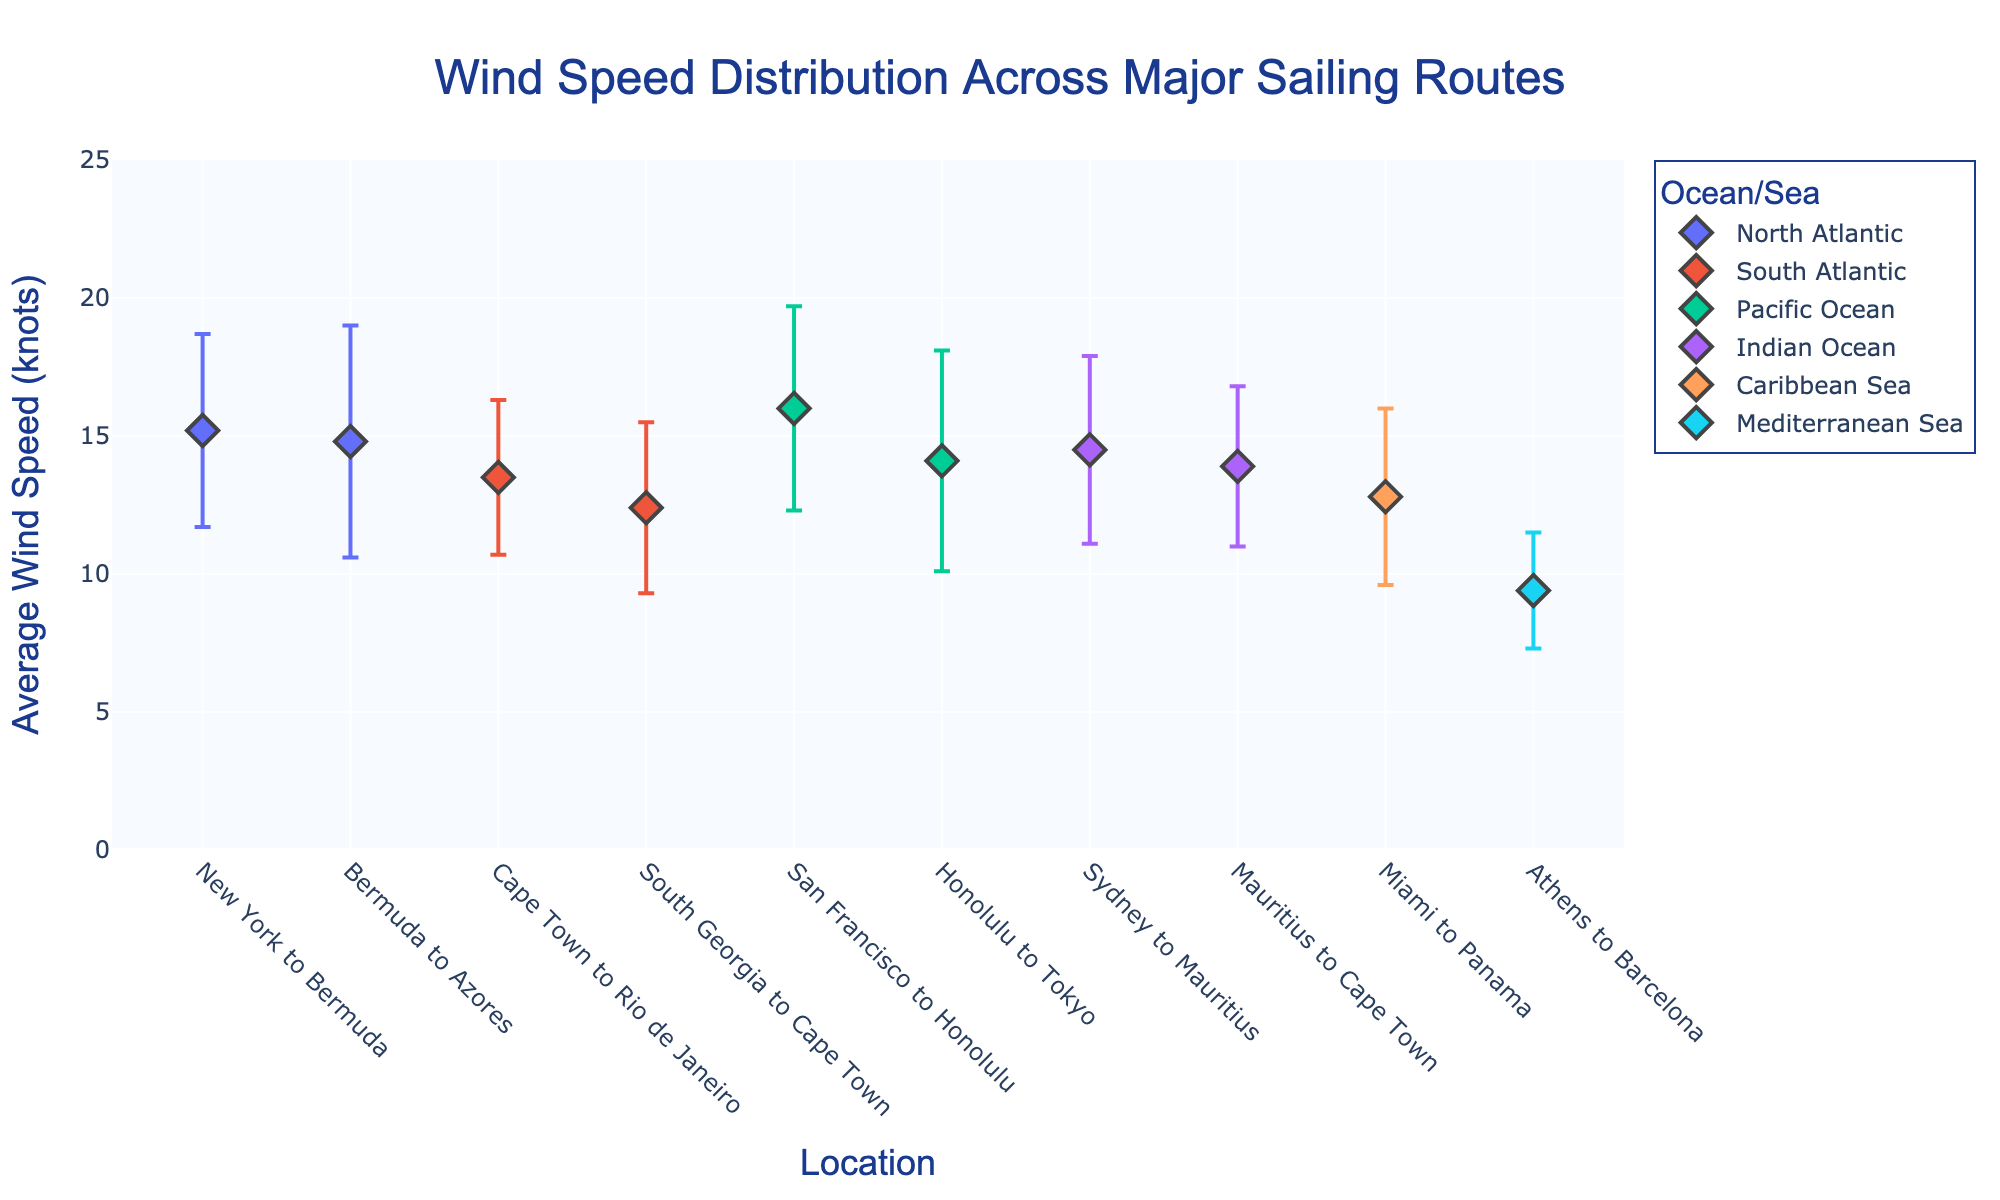What's the average wind speed from San Francisco to Honolulu? The figure includes a data point for the route from San Francisco to Honolulu with an average wind speed labeled on the y-axis.
Answer: 16.0 knots Which route has the highest average wind speed? The highest point on the y-axis will correspond to the highest average wind speed. Identify the route from the x-axis label.
Answer: San Francisco to Honolulu What is the standard deviation of wind speed for the route from Sydney to Mauritius? Locate the data point on the x-axis labeled "Sydney to Mauritius" and observe the error bar for its value annotated.
Answer: 3.4 knots Which route in the Mediterranean Sea has the lowest average wind speed? Look for the data points within the Mediterranean Sea group, then identify the lowest point on the y-axis.
Answer: Athens to Barcelona Comparing the North Atlantic and South Atlantic, which has the lower average wind speed? Identify and compare the average wind speeds (y-axis values) of the routes in both the North Atlantic and South Atlantic groups.
Answer: South Atlantic What's the difference in average wind speed between Miami to Panama and Athens to Barcelona? Subtract the average wind speed of Athens to Barcelona from that of Miami to Panama using their respective y-axis values.
Answer: 12.8 - 9.4 = 3.4 knots Which route has the largest error bar indicating the standard deviation? Identify the data point with the longest error bar on the figure.
Answer: Bermuda to Azores Which locations have wind speeds within the error range of 2 knots? Evaluate the length of the error bars and identify those in which the error bars extend by approximately 2 knots above and below the average.
Answer: Athens to Barcelona Out of routes in the Indian Ocean, which one has the higher average wind speed? Compare the y-axis values for the data points within the Indian Ocean group.
Answer: Sydney to Mauritius 